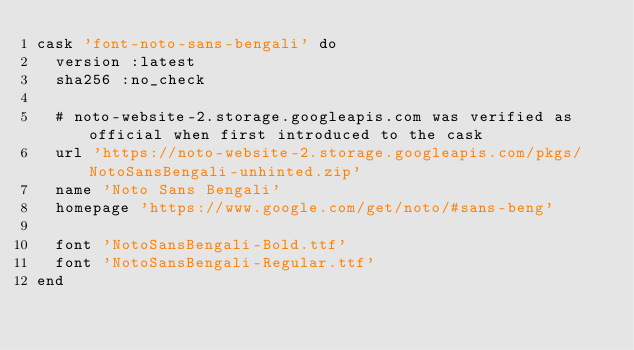<code> <loc_0><loc_0><loc_500><loc_500><_Ruby_>cask 'font-noto-sans-bengali' do
  version :latest
  sha256 :no_check

  # noto-website-2.storage.googleapis.com was verified as official when first introduced to the cask
  url 'https://noto-website-2.storage.googleapis.com/pkgs/NotoSansBengali-unhinted.zip'
  name 'Noto Sans Bengali'
  homepage 'https://www.google.com/get/noto/#sans-beng'

  font 'NotoSansBengali-Bold.ttf'
  font 'NotoSansBengali-Regular.ttf'
end
</code> 